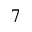Convert formula to latex. <formula><loc_0><loc_0><loc_500><loc_500>^ { 7 }</formula> 